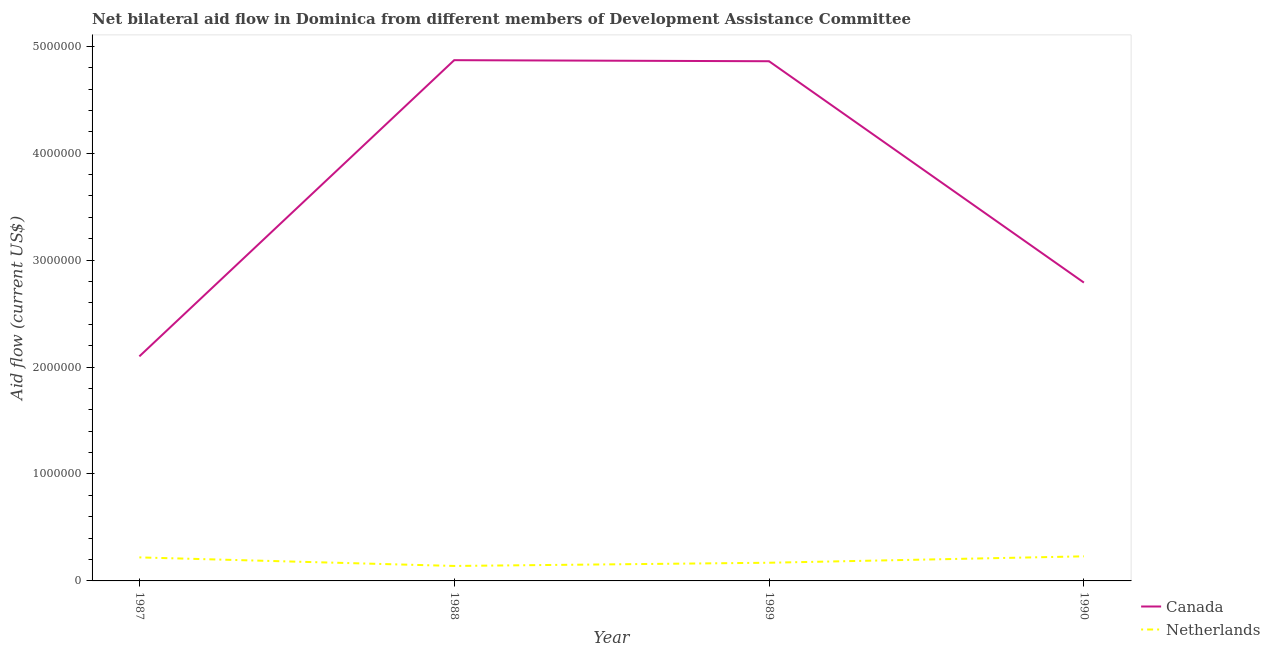How many different coloured lines are there?
Provide a succinct answer. 2. Is the number of lines equal to the number of legend labels?
Provide a succinct answer. Yes. What is the amount of aid given by netherlands in 1989?
Offer a terse response. 1.70e+05. Across all years, what is the maximum amount of aid given by netherlands?
Your response must be concise. 2.30e+05. Across all years, what is the minimum amount of aid given by canada?
Provide a short and direct response. 2.10e+06. In which year was the amount of aid given by netherlands maximum?
Provide a succinct answer. 1990. What is the total amount of aid given by netherlands in the graph?
Make the answer very short. 7.60e+05. What is the difference between the amount of aid given by netherlands in 1989 and that in 1990?
Your answer should be very brief. -6.00e+04. What is the difference between the amount of aid given by canada in 1987 and the amount of aid given by netherlands in 1990?
Provide a short and direct response. 1.87e+06. What is the average amount of aid given by canada per year?
Keep it short and to the point. 3.66e+06. In the year 1988, what is the difference between the amount of aid given by canada and amount of aid given by netherlands?
Provide a short and direct response. 4.73e+06. In how many years, is the amount of aid given by canada greater than 2600000 US$?
Offer a very short reply. 3. What is the ratio of the amount of aid given by canada in 1988 to that in 1989?
Provide a succinct answer. 1. Is the difference between the amount of aid given by netherlands in 1988 and 1989 greater than the difference between the amount of aid given by canada in 1988 and 1989?
Your answer should be very brief. No. What is the difference between the highest and the second highest amount of aid given by netherlands?
Make the answer very short. 10000. What is the difference between the highest and the lowest amount of aid given by netherlands?
Make the answer very short. 9.00e+04. In how many years, is the amount of aid given by canada greater than the average amount of aid given by canada taken over all years?
Provide a succinct answer. 2. Is the sum of the amount of aid given by netherlands in 1987 and 1988 greater than the maximum amount of aid given by canada across all years?
Give a very brief answer. No. Is the amount of aid given by canada strictly greater than the amount of aid given by netherlands over the years?
Ensure brevity in your answer.  Yes. Is the amount of aid given by netherlands strictly less than the amount of aid given by canada over the years?
Make the answer very short. Yes. How many lines are there?
Make the answer very short. 2. How many years are there in the graph?
Offer a very short reply. 4. What is the difference between two consecutive major ticks on the Y-axis?
Provide a short and direct response. 1.00e+06. Does the graph contain grids?
Keep it short and to the point. No. Where does the legend appear in the graph?
Give a very brief answer. Bottom right. How are the legend labels stacked?
Give a very brief answer. Vertical. What is the title of the graph?
Make the answer very short. Net bilateral aid flow in Dominica from different members of Development Assistance Committee. Does "current US$" appear as one of the legend labels in the graph?
Make the answer very short. No. What is the label or title of the X-axis?
Your response must be concise. Year. What is the label or title of the Y-axis?
Offer a very short reply. Aid flow (current US$). What is the Aid flow (current US$) in Canada in 1987?
Your answer should be very brief. 2.10e+06. What is the Aid flow (current US$) of Netherlands in 1987?
Offer a terse response. 2.20e+05. What is the Aid flow (current US$) of Canada in 1988?
Your answer should be compact. 4.87e+06. What is the Aid flow (current US$) of Netherlands in 1988?
Provide a succinct answer. 1.40e+05. What is the Aid flow (current US$) of Canada in 1989?
Give a very brief answer. 4.86e+06. What is the Aid flow (current US$) of Canada in 1990?
Keep it short and to the point. 2.79e+06. What is the Aid flow (current US$) in Netherlands in 1990?
Keep it short and to the point. 2.30e+05. Across all years, what is the maximum Aid flow (current US$) of Canada?
Offer a terse response. 4.87e+06. Across all years, what is the minimum Aid flow (current US$) in Canada?
Make the answer very short. 2.10e+06. What is the total Aid flow (current US$) of Canada in the graph?
Your answer should be very brief. 1.46e+07. What is the total Aid flow (current US$) in Netherlands in the graph?
Provide a succinct answer. 7.60e+05. What is the difference between the Aid flow (current US$) in Canada in 1987 and that in 1988?
Your response must be concise. -2.77e+06. What is the difference between the Aid flow (current US$) in Netherlands in 1987 and that in 1988?
Provide a short and direct response. 8.00e+04. What is the difference between the Aid flow (current US$) of Canada in 1987 and that in 1989?
Provide a succinct answer. -2.76e+06. What is the difference between the Aid flow (current US$) in Canada in 1987 and that in 1990?
Offer a terse response. -6.90e+05. What is the difference between the Aid flow (current US$) of Netherlands in 1988 and that in 1989?
Your answer should be very brief. -3.00e+04. What is the difference between the Aid flow (current US$) in Canada in 1988 and that in 1990?
Keep it short and to the point. 2.08e+06. What is the difference between the Aid flow (current US$) in Canada in 1989 and that in 1990?
Provide a succinct answer. 2.07e+06. What is the difference between the Aid flow (current US$) of Netherlands in 1989 and that in 1990?
Ensure brevity in your answer.  -6.00e+04. What is the difference between the Aid flow (current US$) in Canada in 1987 and the Aid flow (current US$) in Netherlands in 1988?
Keep it short and to the point. 1.96e+06. What is the difference between the Aid flow (current US$) of Canada in 1987 and the Aid flow (current US$) of Netherlands in 1989?
Make the answer very short. 1.93e+06. What is the difference between the Aid flow (current US$) of Canada in 1987 and the Aid flow (current US$) of Netherlands in 1990?
Your answer should be very brief. 1.87e+06. What is the difference between the Aid flow (current US$) in Canada in 1988 and the Aid flow (current US$) in Netherlands in 1989?
Make the answer very short. 4.70e+06. What is the difference between the Aid flow (current US$) in Canada in 1988 and the Aid flow (current US$) in Netherlands in 1990?
Offer a very short reply. 4.64e+06. What is the difference between the Aid flow (current US$) in Canada in 1989 and the Aid flow (current US$) in Netherlands in 1990?
Provide a succinct answer. 4.63e+06. What is the average Aid flow (current US$) of Canada per year?
Your answer should be very brief. 3.66e+06. In the year 1987, what is the difference between the Aid flow (current US$) in Canada and Aid flow (current US$) in Netherlands?
Offer a terse response. 1.88e+06. In the year 1988, what is the difference between the Aid flow (current US$) of Canada and Aid flow (current US$) of Netherlands?
Offer a very short reply. 4.73e+06. In the year 1989, what is the difference between the Aid flow (current US$) of Canada and Aid flow (current US$) of Netherlands?
Your response must be concise. 4.69e+06. In the year 1990, what is the difference between the Aid flow (current US$) in Canada and Aid flow (current US$) in Netherlands?
Keep it short and to the point. 2.56e+06. What is the ratio of the Aid flow (current US$) of Canada in 1987 to that in 1988?
Your answer should be very brief. 0.43. What is the ratio of the Aid flow (current US$) in Netherlands in 1987 to that in 1988?
Provide a succinct answer. 1.57. What is the ratio of the Aid flow (current US$) of Canada in 1987 to that in 1989?
Provide a short and direct response. 0.43. What is the ratio of the Aid flow (current US$) in Netherlands in 1987 to that in 1989?
Provide a short and direct response. 1.29. What is the ratio of the Aid flow (current US$) in Canada in 1987 to that in 1990?
Offer a terse response. 0.75. What is the ratio of the Aid flow (current US$) of Netherlands in 1987 to that in 1990?
Give a very brief answer. 0.96. What is the ratio of the Aid flow (current US$) of Netherlands in 1988 to that in 1989?
Give a very brief answer. 0.82. What is the ratio of the Aid flow (current US$) of Canada in 1988 to that in 1990?
Make the answer very short. 1.75. What is the ratio of the Aid flow (current US$) of Netherlands in 1988 to that in 1990?
Ensure brevity in your answer.  0.61. What is the ratio of the Aid flow (current US$) of Canada in 1989 to that in 1990?
Give a very brief answer. 1.74. What is the ratio of the Aid flow (current US$) in Netherlands in 1989 to that in 1990?
Your answer should be compact. 0.74. What is the difference between the highest and the second highest Aid flow (current US$) in Canada?
Keep it short and to the point. 10000. What is the difference between the highest and the second highest Aid flow (current US$) in Netherlands?
Make the answer very short. 10000. What is the difference between the highest and the lowest Aid flow (current US$) of Canada?
Offer a very short reply. 2.77e+06. 